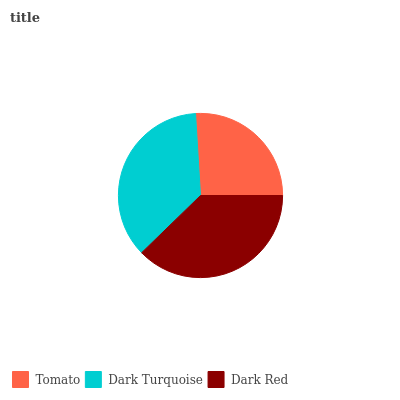Is Tomato the minimum?
Answer yes or no. Yes. Is Dark Red the maximum?
Answer yes or no. Yes. Is Dark Turquoise the minimum?
Answer yes or no. No. Is Dark Turquoise the maximum?
Answer yes or no. No. Is Dark Turquoise greater than Tomato?
Answer yes or no. Yes. Is Tomato less than Dark Turquoise?
Answer yes or no. Yes. Is Tomato greater than Dark Turquoise?
Answer yes or no. No. Is Dark Turquoise less than Tomato?
Answer yes or no. No. Is Dark Turquoise the high median?
Answer yes or no. Yes. Is Dark Turquoise the low median?
Answer yes or no. Yes. Is Dark Red the high median?
Answer yes or no. No. Is Dark Red the low median?
Answer yes or no. No. 